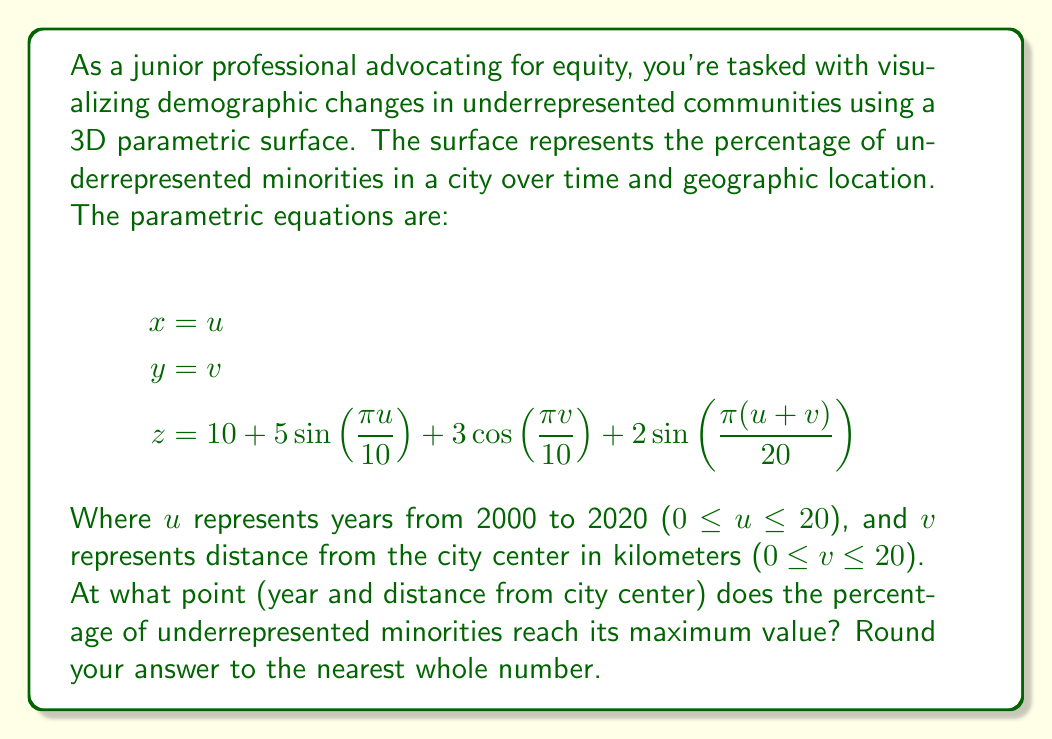Could you help me with this problem? To find the maximum value of z (percentage of underrepresented minorities), we need to analyze the function:

$$z = 10 + 5\sin(\frac{\pi u}{10}) + 3\cos(\frac{\pi v}{10}) + 2\sin(\frac{\pi(u+v)}{20})$$

1. The maximum value will occur when each trigonometric term is at its maximum:
   - $\sin(\frac{\pi u}{10})$ is maximum when $\frac{\pi u}{10} = \frac{\pi}{2}$, so $u = 5$
   - $\cos(\frac{\pi v}{10})$ is maximum when $\frac{\pi v}{10} = 0$, so $v = 0$
   - $\sin(\frac{\pi(u+v)}{20})$ is maximum when $\frac{\pi(u+v)}{20} = \frac{\pi}{2}$, so $u + v = 10$

2. We can see that these conditions can't be simultaneously satisfied. However, we can get close by choosing $u = 5$ and $v = 5$:

   $$z = 10 + 5\sin(\frac{\pi \cdot 5}{10}) + 3\cos(\frac{\pi \cdot 5}{10}) + 2\sin(\frac{\pi(5+5)}{20})$$
   $$= 10 + 5\sin(\frac{\pi}{2}) + 3\cos(\frac{\pi}{2}) + 2\sin(\frac{\pi}{2})$$
   $$= 10 + 5 + 0 + 2 = 17$$

3. To verify this is indeed the maximum, we could use calculus to find the partial derivatives and critical points, or use a computer to evaluate the function at all integer points in the domain.

4. Interpreting the result:
   - $u = 5$ corresponds to the year 2005 (5 years after 2000)
   - $v = 5$ corresponds to 5 km from the city center

Therefore, the maximum percentage of underrepresented minorities occurs in 2005, 5 km from the city center.
Answer: (2005, 5) 